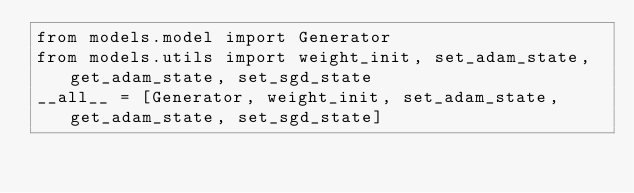<code> <loc_0><loc_0><loc_500><loc_500><_Python_>from models.model import Generator
from models.utils import weight_init, set_adam_state, get_adam_state, set_sgd_state
__all__ = [Generator, weight_init, set_adam_state, get_adam_state, set_sgd_state]</code> 